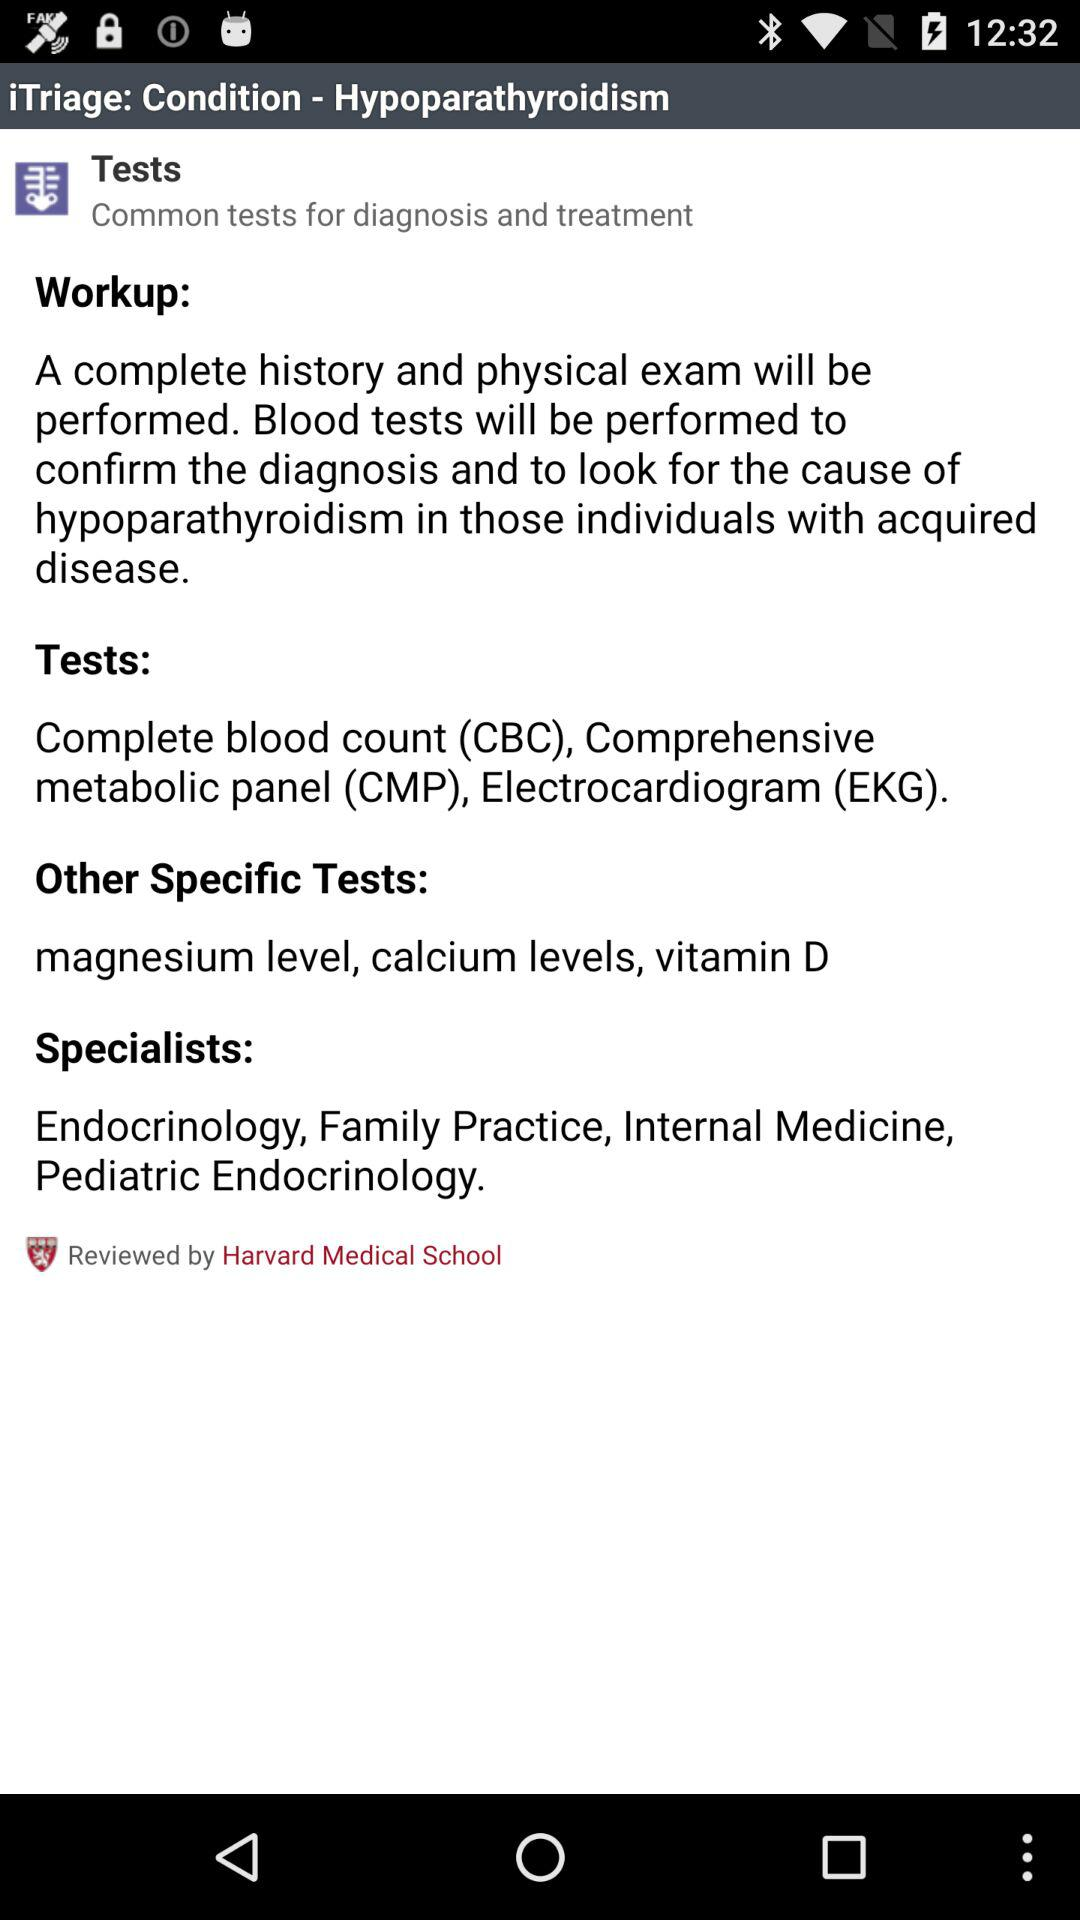What medical school has it been reviewed by? It has been reviewed by the "Harvard Medical School". 